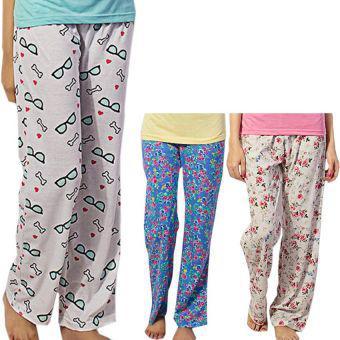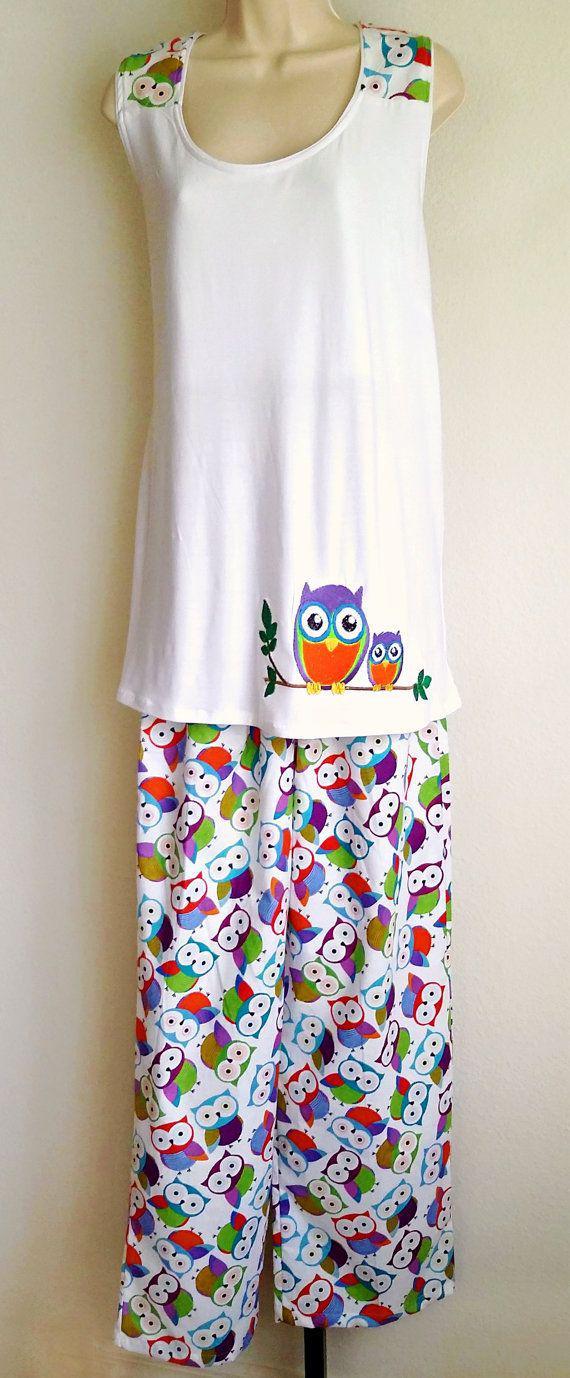The first image is the image on the left, the second image is the image on the right. Analyze the images presented: Is the assertion "Each image contains one outfit consisting of printed pajama pants and a coordinating top featuring the same printed pattern." valid? Answer yes or no. No. The first image is the image on the left, the second image is the image on the right. Analyze the images presented: Is the assertion "A pajama set with an overall print design has wide cuffs on its long pants and long sleeved shirt, and a rounded collar on the shirt." valid? Answer yes or no. No. 